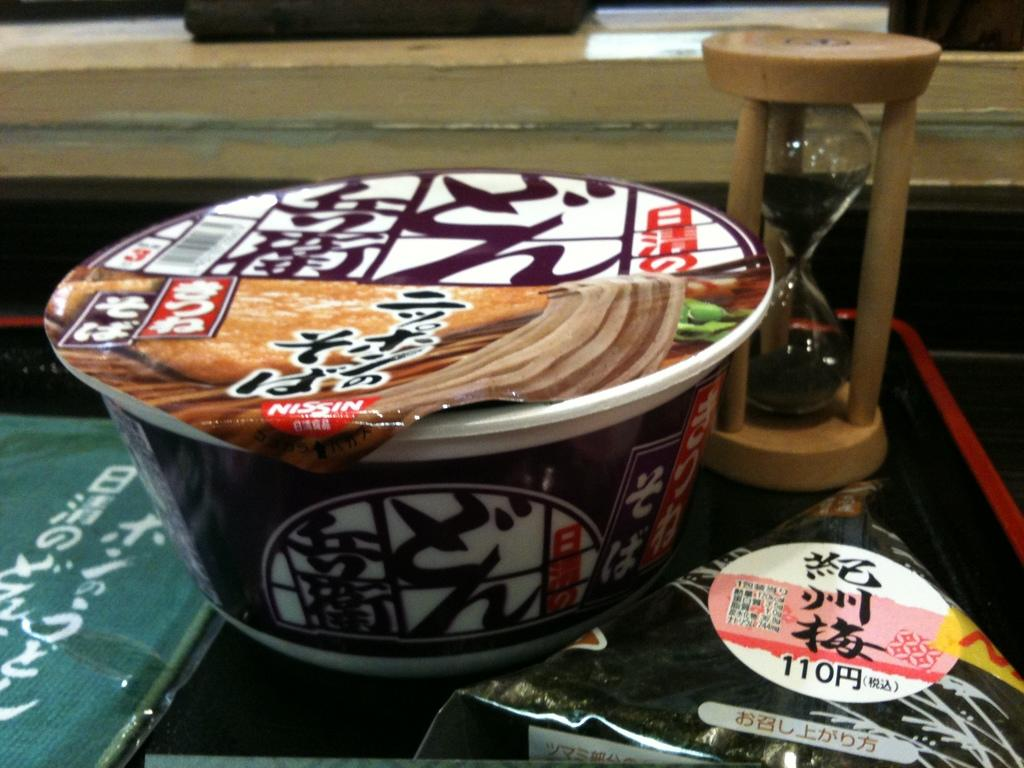What is one of the main objects in the image? There is a cup in the image. What other object can be seen alongside the cup? There is a sand timer in the image. What is in front of the cup and sand timer? There are objects in front of the cup and sand timer. What can be seen in the background of the image? There is wood visible in the background of the image. What type of cheese is being used to turn the wheel in the image? There is no cheese or wheel present in the image. 